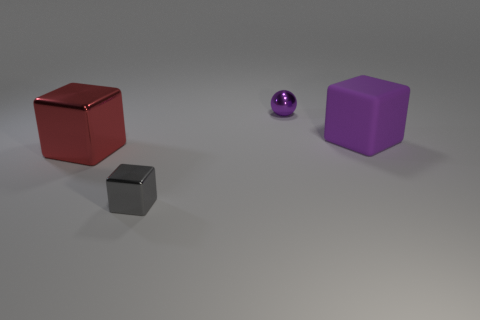What might be the texture of the surface on which the objects are placed? The surface appears smooth and has a slight reflective quality, suggestive of a polished concrete or a matte metal. There are no visible grains or textures that would imply a rougher material. 